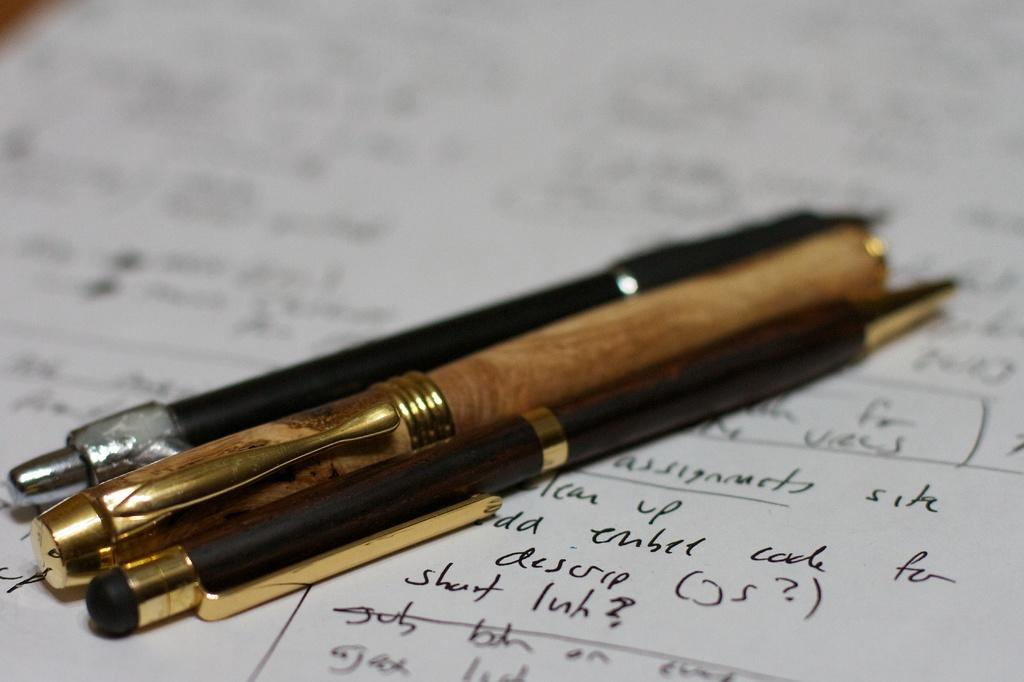Provide a one-sentence caption for the provided image. Three pens on a sheet of paper with a bunch of writing including a line that say descr. 